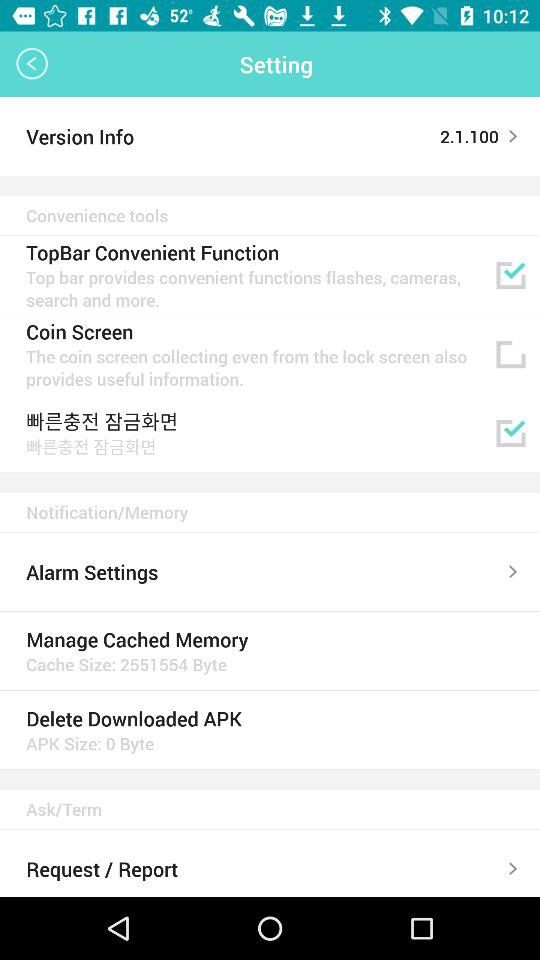What is the size of cache memory? The size of cache memory is 2551554 bytes. 